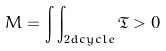Convert formula to latex. <formula><loc_0><loc_0><loc_500><loc_500>M = \int \int _ { 2 d c y c l e } \mathfrak { T } > 0</formula> 